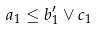Convert formula to latex. <formula><loc_0><loc_0><loc_500><loc_500>a _ { 1 } \leq b ^ { \prime } _ { 1 } \vee c _ { 1 }</formula> 